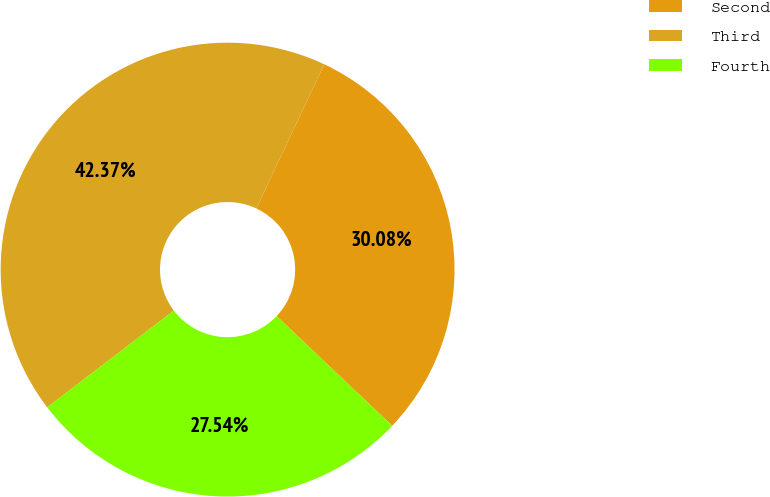Convert chart to OTSL. <chart><loc_0><loc_0><loc_500><loc_500><pie_chart><fcel>Second<fcel>Third<fcel>Fourth<nl><fcel>30.08%<fcel>42.37%<fcel>27.54%<nl></chart> 